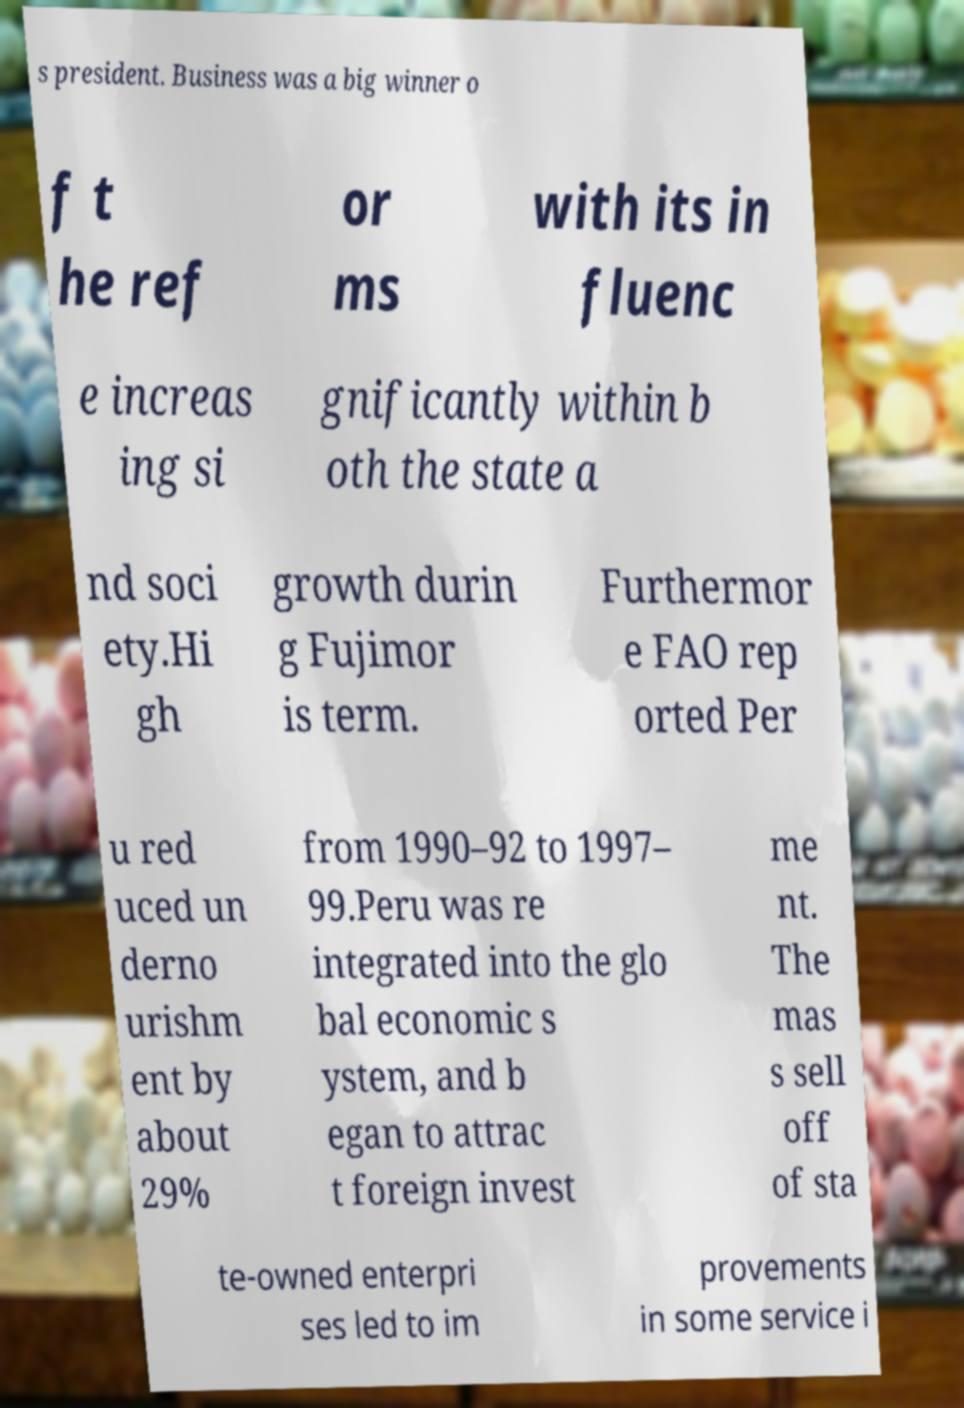Can you read and provide the text displayed in the image?This photo seems to have some interesting text. Can you extract and type it out for me? s president. Business was a big winner o f t he ref or ms with its in fluenc e increas ing si gnificantly within b oth the state a nd soci ety.Hi gh growth durin g Fujimor is term. Furthermor e FAO rep orted Per u red uced un derno urishm ent by about 29% from 1990–92 to 1997– 99.Peru was re integrated into the glo bal economic s ystem, and b egan to attrac t foreign invest me nt. The mas s sell off of sta te-owned enterpri ses led to im provements in some service i 